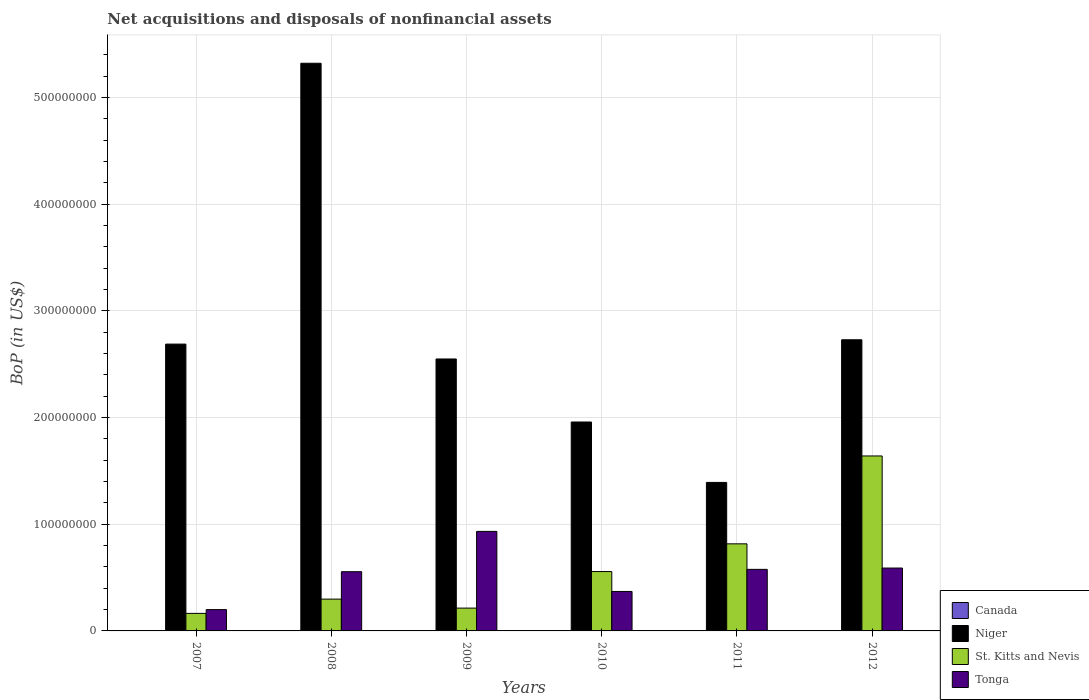Are the number of bars per tick equal to the number of legend labels?
Make the answer very short. No. How many bars are there on the 4th tick from the left?
Your answer should be very brief. 3. What is the Balance of Payments in Tonga in 2010?
Give a very brief answer. 3.70e+07. Across all years, what is the maximum Balance of Payments in Tonga?
Make the answer very short. 9.33e+07. Across all years, what is the minimum Balance of Payments in Niger?
Ensure brevity in your answer.  1.39e+08. What is the total Balance of Payments in Niger in the graph?
Your response must be concise. 1.66e+09. What is the difference between the Balance of Payments in St. Kitts and Nevis in 2007 and that in 2012?
Ensure brevity in your answer.  -1.48e+08. What is the difference between the Balance of Payments in Niger in 2009 and the Balance of Payments in St. Kitts and Nevis in 2012?
Offer a terse response. 9.09e+07. What is the average Balance of Payments in Tonga per year?
Give a very brief answer. 5.37e+07. In the year 2010, what is the difference between the Balance of Payments in St. Kitts and Nevis and Balance of Payments in Tonga?
Your answer should be very brief. 1.87e+07. What is the ratio of the Balance of Payments in Niger in 2009 to that in 2012?
Offer a very short reply. 0.93. Is the Balance of Payments in Niger in 2007 less than that in 2010?
Make the answer very short. No. Is the difference between the Balance of Payments in St. Kitts and Nevis in 2007 and 2009 greater than the difference between the Balance of Payments in Tonga in 2007 and 2009?
Offer a terse response. Yes. What is the difference between the highest and the second highest Balance of Payments in Tonga?
Your response must be concise. 3.43e+07. What is the difference between the highest and the lowest Balance of Payments in Niger?
Provide a short and direct response. 3.93e+08. Is it the case that in every year, the sum of the Balance of Payments in Tonga and Balance of Payments in Niger is greater than the Balance of Payments in St. Kitts and Nevis?
Your answer should be compact. Yes. Are all the bars in the graph horizontal?
Your answer should be compact. No. How many years are there in the graph?
Your response must be concise. 6. Are the values on the major ticks of Y-axis written in scientific E-notation?
Your response must be concise. No. Does the graph contain any zero values?
Your response must be concise. Yes. Where does the legend appear in the graph?
Ensure brevity in your answer.  Bottom right. What is the title of the graph?
Your response must be concise. Net acquisitions and disposals of nonfinancial assets. Does "Lithuania" appear as one of the legend labels in the graph?
Ensure brevity in your answer.  No. What is the label or title of the X-axis?
Your answer should be very brief. Years. What is the label or title of the Y-axis?
Your answer should be very brief. BoP (in US$). What is the BoP (in US$) in Canada in 2007?
Keep it short and to the point. 0. What is the BoP (in US$) of Niger in 2007?
Offer a terse response. 2.69e+08. What is the BoP (in US$) in St. Kitts and Nevis in 2007?
Your answer should be very brief. 1.64e+07. What is the BoP (in US$) of Tonga in 2007?
Give a very brief answer. 2.00e+07. What is the BoP (in US$) in Niger in 2008?
Your answer should be very brief. 5.32e+08. What is the BoP (in US$) of St. Kitts and Nevis in 2008?
Make the answer very short. 2.98e+07. What is the BoP (in US$) of Tonga in 2008?
Provide a succinct answer. 5.55e+07. What is the BoP (in US$) in Canada in 2009?
Provide a succinct answer. 0. What is the BoP (in US$) in Niger in 2009?
Keep it short and to the point. 2.55e+08. What is the BoP (in US$) of St. Kitts and Nevis in 2009?
Provide a succinct answer. 2.14e+07. What is the BoP (in US$) of Tonga in 2009?
Your answer should be very brief. 9.33e+07. What is the BoP (in US$) in Canada in 2010?
Make the answer very short. 0. What is the BoP (in US$) in Niger in 2010?
Offer a very short reply. 1.96e+08. What is the BoP (in US$) of St. Kitts and Nevis in 2010?
Give a very brief answer. 5.56e+07. What is the BoP (in US$) of Tonga in 2010?
Offer a very short reply. 3.70e+07. What is the BoP (in US$) of Canada in 2011?
Your answer should be compact. 0. What is the BoP (in US$) of Niger in 2011?
Provide a short and direct response. 1.39e+08. What is the BoP (in US$) of St. Kitts and Nevis in 2011?
Provide a short and direct response. 8.16e+07. What is the BoP (in US$) of Tonga in 2011?
Give a very brief answer. 5.77e+07. What is the BoP (in US$) in Canada in 2012?
Ensure brevity in your answer.  0. What is the BoP (in US$) of Niger in 2012?
Give a very brief answer. 2.73e+08. What is the BoP (in US$) of St. Kitts and Nevis in 2012?
Provide a succinct answer. 1.64e+08. What is the BoP (in US$) of Tonga in 2012?
Keep it short and to the point. 5.89e+07. Across all years, what is the maximum BoP (in US$) of Niger?
Provide a succinct answer. 5.32e+08. Across all years, what is the maximum BoP (in US$) in St. Kitts and Nevis?
Keep it short and to the point. 1.64e+08. Across all years, what is the maximum BoP (in US$) of Tonga?
Keep it short and to the point. 9.33e+07. Across all years, what is the minimum BoP (in US$) in Niger?
Ensure brevity in your answer.  1.39e+08. Across all years, what is the minimum BoP (in US$) of St. Kitts and Nevis?
Your response must be concise. 1.64e+07. Across all years, what is the minimum BoP (in US$) in Tonga?
Keep it short and to the point. 2.00e+07. What is the total BoP (in US$) of Niger in the graph?
Ensure brevity in your answer.  1.66e+09. What is the total BoP (in US$) in St. Kitts and Nevis in the graph?
Ensure brevity in your answer.  3.69e+08. What is the total BoP (in US$) in Tonga in the graph?
Offer a terse response. 3.22e+08. What is the difference between the BoP (in US$) of Niger in 2007 and that in 2008?
Make the answer very short. -2.63e+08. What is the difference between the BoP (in US$) of St. Kitts and Nevis in 2007 and that in 2008?
Ensure brevity in your answer.  -1.34e+07. What is the difference between the BoP (in US$) of Tonga in 2007 and that in 2008?
Your response must be concise. -3.55e+07. What is the difference between the BoP (in US$) in Niger in 2007 and that in 2009?
Keep it short and to the point. 1.39e+07. What is the difference between the BoP (in US$) of St. Kitts and Nevis in 2007 and that in 2009?
Offer a terse response. -4.94e+06. What is the difference between the BoP (in US$) in Tonga in 2007 and that in 2009?
Keep it short and to the point. -7.33e+07. What is the difference between the BoP (in US$) of Niger in 2007 and that in 2010?
Your answer should be compact. 7.30e+07. What is the difference between the BoP (in US$) in St. Kitts and Nevis in 2007 and that in 2010?
Provide a succinct answer. -3.92e+07. What is the difference between the BoP (in US$) of Tonga in 2007 and that in 2010?
Your answer should be compact. -1.70e+07. What is the difference between the BoP (in US$) of Niger in 2007 and that in 2011?
Your answer should be compact. 1.30e+08. What is the difference between the BoP (in US$) in St. Kitts and Nevis in 2007 and that in 2011?
Offer a very short reply. -6.52e+07. What is the difference between the BoP (in US$) in Tonga in 2007 and that in 2011?
Ensure brevity in your answer.  -3.77e+07. What is the difference between the BoP (in US$) of Niger in 2007 and that in 2012?
Keep it short and to the point. -4.05e+06. What is the difference between the BoP (in US$) in St. Kitts and Nevis in 2007 and that in 2012?
Keep it short and to the point. -1.48e+08. What is the difference between the BoP (in US$) of Tonga in 2007 and that in 2012?
Your answer should be compact. -3.90e+07. What is the difference between the BoP (in US$) in Niger in 2008 and that in 2009?
Keep it short and to the point. 2.77e+08. What is the difference between the BoP (in US$) of St. Kitts and Nevis in 2008 and that in 2009?
Offer a terse response. 8.42e+06. What is the difference between the BoP (in US$) in Tonga in 2008 and that in 2009?
Give a very brief answer. -3.78e+07. What is the difference between the BoP (in US$) of Niger in 2008 and that in 2010?
Your answer should be very brief. 3.36e+08. What is the difference between the BoP (in US$) of St. Kitts and Nevis in 2008 and that in 2010?
Your response must be concise. -2.58e+07. What is the difference between the BoP (in US$) in Tonga in 2008 and that in 2010?
Your answer should be compact. 1.85e+07. What is the difference between the BoP (in US$) in Niger in 2008 and that in 2011?
Your answer should be very brief. 3.93e+08. What is the difference between the BoP (in US$) of St. Kitts and Nevis in 2008 and that in 2011?
Provide a succinct answer. -5.18e+07. What is the difference between the BoP (in US$) of Tonga in 2008 and that in 2011?
Give a very brief answer. -2.19e+06. What is the difference between the BoP (in US$) in Niger in 2008 and that in 2012?
Your answer should be compact. 2.59e+08. What is the difference between the BoP (in US$) of St. Kitts and Nevis in 2008 and that in 2012?
Make the answer very short. -1.34e+08. What is the difference between the BoP (in US$) in Tonga in 2008 and that in 2012?
Give a very brief answer. -3.43e+06. What is the difference between the BoP (in US$) of Niger in 2009 and that in 2010?
Provide a succinct answer. 5.91e+07. What is the difference between the BoP (in US$) in St. Kitts and Nevis in 2009 and that in 2010?
Your response must be concise. -3.43e+07. What is the difference between the BoP (in US$) of Tonga in 2009 and that in 2010?
Give a very brief answer. 5.63e+07. What is the difference between the BoP (in US$) of Niger in 2009 and that in 2011?
Make the answer very short. 1.16e+08. What is the difference between the BoP (in US$) in St. Kitts and Nevis in 2009 and that in 2011?
Your response must be concise. -6.02e+07. What is the difference between the BoP (in US$) of Tonga in 2009 and that in 2011?
Offer a very short reply. 3.56e+07. What is the difference between the BoP (in US$) of Niger in 2009 and that in 2012?
Provide a short and direct response. -1.80e+07. What is the difference between the BoP (in US$) in St. Kitts and Nevis in 2009 and that in 2012?
Offer a very short reply. -1.43e+08. What is the difference between the BoP (in US$) of Tonga in 2009 and that in 2012?
Provide a succinct answer. 3.43e+07. What is the difference between the BoP (in US$) of Niger in 2010 and that in 2011?
Your response must be concise. 5.66e+07. What is the difference between the BoP (in US$) of St. Kitts and Nevis in 2010 and that in 2011?
Provide a succinct answer. -2.60e+07. What is the difference between the BoP (in US$) in Tonga in 2010 and that in 2011?
Your response must be concise. -2.07e+07. What is the difference between the BoP (in US$) in Niger in 2010 and that in 2012?
Provide a short and direct response. -7.71e+07. What is the difference between the BoP (in US$) in St. Kitts and Nevis in 2010 and that in 2012?
Make the answer very short. -1.08e+08. What is the difference between the BoP (in US$) of Tonga in 2010 and that in 2012?
Keep it short and to the point. -2.20e+07. What is the difference between the BoP (in US$) of Niger in 2011 and that in 2012?
Offer a very short reply. -1.34e+08. What is the difference between the BoP (in US$) of St. Kitts and Nevis in 2011 and that in 2012?
Your answer should be very brief. -8.24e+07. What is the difference between the BoP (in US$) in Tonga in 2011 and that in 2012?
Make the answer very short. -1.24e+06. What is the difference between the BoP (in US$) in Niger in 2007 and the BoP (in US$) in St. Kitts and Nevis in 2008?
Make the answer very short. 2.39e+08. What is the difference between the BoP (in US$) in Niger in 2007 and the BoP (in US$) in Tonga in 2008?
Ensure brevity in your answer.  2.13e+08. What is the difference between the BoP (in US$) of St. Kitts and Nevis in 2007 and the BoP (in US$) of Tonga in 2008?
Your answer should be compact. -3.91e+07. What is the difference between the BoP (in US$) of Niger in 2007 and the BoP (in US$) of St. Kitts and Nevis in 2009?
Your response must be concise. 2.47e+08. What is the difference between the BoP (in US$) in Niger in 2007 and the BoP (in US$) in Tonga in 2009?
Ensure brevity in your answer.  1.76e+08. What is the difference between the BoP (in US$) of St. Kitts and Nevis in 2007 and the BoP (in US$) of Tonga in 2009?
Your answer should be compact. -7.68e+07. What is the difference between the BoP (in US$) in Niger in 2007 and the BoP (in US$) in St. Kitts and Nevis in 2010?
Provide a succinct answer. 2.13e+08. What is the difference between the BoP (in US$) in Niger in 2007 and the BoP (in US$) in Tonga in 2010?
Offer a terse response. 2.32e+08. What is the difference between the BoP (in US$) of St. Kitts and Nevis in 2007 and the BoP (in US$) of Tonga in 2010?
Keep it short and to the point. -2.05e+07. What is the difference between the BoP (in US$) in Niger in 2007 and the BoP (in US$) in St. Kitts and Nevis in 2011?
Keep it short and to the point. 1.87e+08. What is the difference between the BoP (in US$) of Niger in 2007 and the BoP (in US$) of Tonga in 2011?
Keep it short and to the point. 2.11e+08. What is the difference between the BoP (in US$) in St. Kitts and Nevis in 2007 and the BoP (in US$) in Tonga in 2011?
Your answer should be very brief. -4.13e+07. What is the difference between the BoP (in US$) in Niger in 2007 and the BoP (in US$) in St. Kitts and Nevis in 2012?
Offer a terse response. 1.05e+08. What is the difference between the BoP (in US$) in Niger in 2007 and the BoP (in US$) in Tonga in 2012?
Provide a succinct answer. 2.10e+08. What is the difference between the BoP (in US$) of St. Kitts and Nevis in 2007 and the BoP (in US$) of Tonga in 2012?
Provide a succinct answer. -4.25e+07. What is the difference between the BoP (in US$) in Niger in 2008 and the BoP (in US$) in St. Kitts and Nevis in 2009?
Provide a succinct answer. 5.11e+08. What is the difference between the BoP (in US$) in Niger in 2008 and the BoP (in US$) in Tonga in 2009?
Provide a succinct answer. 4.39e+08. What is the difference between the BoP (in US$) in St. Kitts and Nevis in 2008 and the BoP (in US$) in Tonga in 2009?
Make the answer very short. -6.35e+07. What is the difference between the BoP (in US$) in Niger in 2008 and the BoP (in US$) in St. Kitts and Nevis in 2010?
Provide a short and direct response. 4.76e+08. What is the difference between the BoP (in US$) in Niger in 2008 and the BoP (in US$) in Tonga in 2010?
Ensure brevity in your answer.  4.95e+08. What is the difference between the BoP (in US$) of St. Kitts and Nevis in 2008 and the BoP (in US$) of Tonga in 2010?
Provide a succinct answer. -7.18e+06. What is the difference between the BoP (in US$) in Niger in 2008 and the BoP (in US$) in St. Kitts and Nevis in 2011?
Ensure brevity in your answer.  4.50e+08. What is the difference between the BoP (in US$) of Niger in 2008 and the BoP (in US$) of Tonga in 2011?
Your response must be concise. 4.74e+08. What is the difference between the BoP (in US$) in St. Kitts and Nevis in 2008 and the BoP (in US$) in Tonga in 2011?
Provide a succinct answer. -2.79e+07. What is the difference between the BoP (in US$) of Niger in 2008 and the BoP (in US$) of St. Kitts and Nevis in 2012?
Give a very brief answer. 3.68e+08. What is the difference between the BoP (in US$) in Niger in 2008 and the BoP (in US$) in Tonga in 2012?
Your answer should be very brief. 4.73e+08. What is the difference between the BoP (in US$) of St. Kitts and Nevis in 2008 and the BoP (in US$) of Tonga in 2012?
Offer a terse response. -2.91e+07. What is the difference between the BoP (in US$) of Niger in 2009 and the BoP (in US$) of St. Kitts and Nevis in 2010?
Keep it short and to the point. 1.99e+08. What is the difference between the BoP (in US$) in Niger in 2009 and the BoP (in US$) in Tonga in 2010?
Keep it short and to the point. 2.18e+08. What is the difference between the BoP (in US$) of St. Kitts and Nevis in 2009 and the BoP (in US$) of Tonga in 2010?
Ensure brevity in your answer.  -1.56e+07. What is the difference between the BoP (in US$) in Niger in 2009 and the BoP (in US$) in St. Kitts and Nevis in 2011?
Your response must be concise. 1.73e+08. What is the difference between the BoP (in US$) in Niger in 2009 and the BoP (in US$) in Tonga in 2011?
Your answer should be compact. 1.97e+08. What is the difference between the BoP (in US$) in St. Kitts and Nevis in 2009 and the BoP (in US$) in Tonga in 2011?
Give a very brief answer. -3.63e+07. What is the difference between the BoP (in US$) of Niger in 2009 and the BoP (in US$) of St. Kitts and Nevis in 2012?
Your response must be concise. 9.09e+07. What is the difference between the BoP (in US$) in Niger in 2009 and the BoP (in US$) in Tonga in 2012?
Ensure brevity in your answer.  1.96e+08. What is the difference between the BoP (in US$) in St. Kitts and Nevis in 2009 and the BoP (in US$) in Tonga in 2012?
Offer a terse response. -3.76e+07. What is the difference between the BoP (in US$) in Niger in 2010 and the BoP (in US$) in St. Kitts and Nevis in 2011?
Provide a succinct answer. 1.14e+08. What is the difference between the BoP (in US$) in Niger in 2010 and the BoP (in US$) in Tonga in 2011?
Your response must be concise. 1.38e+08. What is the difference between the BoP (in US$) of St. Kitts and Nevis in 2010 and the BoP (in US$) of Tonga in 2011?
Your answer should be compact. -2.05e+06. What is the difference between the BoP (in US$) in Niger in 2010 and the BoP (in US$) in St. Kitts and Nevis in 2012?
Keep it short and to the point. 3.18e+07. What is the difference between the BoP (in US$) in Niger in 2010 and the BoP (in US$) in Tonga in 2012?
Your response must be concise. 1.37e+08. What is the difference between the BoP (in US$) in St. Kitts and Nevis in 2010 and the BoP (in US$) in Tonga in 2012?
Give a very brief answer. -3.30e+06. What is the difference between the BoP (in US$) of Niger in 2011 and the BoP (in US$) of St. Kitts and Nevis in 2012?
Keep it short and to the point. -2.48e+07. What is the difference between the BoP (in US$) of Niger in 2011 and the BoP (in US$) of Tonga in 2012?
Keep it short and to the point. 8.03e+07. What is the difference between the BoP (in US$) in St. Kitts and Nevis in 2011 and the BoP (in US$) in Tonga in 2012?
Provide a short and direct response. 2.27e+07. What is the average BoP (in US$) of Canada per year?
Ensure brevity in your answer.  0. What is the average BoP (in US$) in Niger per year?
Your answer should be very brief. 2.77e+08. What is the average BoP (in US$) of St. Kitts and Nevis per year?
Provide a succinct answer. 6.15e+07. What is the average BoP (in US$) of Tonga per year?
Ensure brevity in your answer.  5.37e+07. In the year 2007, what is the difference between the BoP (in US$) of Niger and BoP (in US$) of St. Kitts and Nevis?
Ensure brevity in your answer.  2.52e+08. In the year 2007, what is the difference between the BoP (in US$) of Niger and BoP (in US$) of Tonga?
Your answer should be compact. 2.49e+08. In the year 2007, what is the difference between the BoP (in US$) in St. Kitts and Nevis and BoP (in US$) in Tonga?
Provide a short and direct response. -3.53e+06. In the year 2008, what is the difference between the BoP (in US$) in Niger and BoP (in US$) in St. Kitts and Nevis?
Make the answer very short. 5.02e+08. In the year 2008, what is the difference between the BoP (in US$) of Niger and BoP (in US$) of Tonga?
Offer a very short reply. 4.77e+08. In the year 2008, what is the difference between the BoP (in US$) of St. Kitts and Nevis and BoP (in US$) of Tonga?
Your answer should be very brief. -2.57e+07. In the year 2009, what is the difference between the BoP (in US$) in Niger and BoP (in US$) in St. Kitts and Nevis?
Provide a short and direct response. 2.34e+08. In the year 2009, what is the difference between the BoP (in US$) of Niger and BoP (in US$) of Tonga?
Make the answer very short. 1.62e+08. In the year 2009, what is the difference between the BoP (in US$) in St. Kitts and Nevis and BoP (in US$) in Tonga?
Make the answer very short. -7.19e+07. In the year 2010, what is the difference between the BoP (in US$) in Niger and BoP (in US$) in St. Kitts and Nevis?
Provide a short and direct response. 1.40e+08. In the year 2010, what is the difference between the BoP (in US$) of Niger and BoP (in US$) of Tonga?
Ensure brevity in your answer.  1.59e+08. In the year 2010, what is the difference between the BoP (in US$) of St. Kitts and Nevis and BoP (in US$) of Tonga?
Keep it short and to the point. 1.87e+07. In the year 2011, what is the difference between the BoP (in US$) of Niger and BoP (in US$) of St. Kitts and Nevis?
Keep it short and to the point. 5.76e+07. In the year 2011, what is the difference between the BoP (in US$) of Niger and BoP (in US$) of Tonga?
Your response must be concise. 8.15e+07. In the year 2011, what is the difference between the BoP (in US$) in St. Kitts and Nevis and BoP (in US$) in Tonga?
Provide a short and direct response. 2.39e+07. In the year 2012, what is the difference between the BoP (in US$) of Niger and BoP (in US$) of St. Kitts and Nevis?
Provide a short and direct response. 1.09e+08. In the year 2012, what is the difference between the BoP (in US$) in Niger and BoP (in US$) in Tonga?
Ensure brevity in your answer.  2.14e+08. In the year 2012, what is the difference between the BoP (in US$) in St. Kitts and Nevis and BoP (in US$) in Tonga?
Give a very brief answer. 1.05e+08. What is the ratio of the BoP (in US$) of Niger in 2007 to that in 2008?
Your response must be concise. 0.51. What is the ratio of the BoP (in US$) of St. Kitts and Nevis in 2007 to that in 2008?
Ensure brevity in your answer.  0.55. What is the ratio of the BoP (in US$) in Tonga in 2007 to that in 2008?
Your response must be concise. 0.36. What is the ratio of the BoP (in US$) of Niger in 2007 to that in 2009?
Make the answer very short. 1.05. What is the ratio of the BoP (in US$) of St. Kitts and Nevis in 2007 to that in 2009?
Your response must be concise. 0.77. What is the ratio of the BoP (in US$) in Tonga in 2007 to that in 2009?
Your response must be concise. 0.21. What is the ratio of the BoP (in US$) in Niger in 2007 to that in 2010?
Offer a terse response. 1.37. What is the ratio of the BoP (in US$) of St. Kitts and Nevis in 2007 to that in 2010?
Your answer should be very brief. 0.3. What is the ratio of the BoP (in US$) of Tonga in 2007 to that in 2010?
Give a very brief answer. 0.54. What is the ratio of the BoP (in US$) of Niger in 2007 to that in 2011?
Give a very brief answer. 1.93. What is the ratio of the BoP (in US$) in St. Kitts and Nevis in 2007 to that in 2011?
Ensure brevity in your answer.  0.2. What is the ratio of the BoP (in US$) in Tonga in 2007 to that in 2011?
Your answer should be compact. 0.35. What is the ratio of the BoP (in US$) of Niger in 2007 to that in 2012?
Your answer should be compact. 0.99. What is the ratio of the BoP (in US$) in St. Kitts and Nevis in 2007 to that in 2012?
Offer a terse response. 0.1. What is the ratio of the BoP (in US$) in Tonga in 2007 to that in 2012?
Make the answer very short. 0.34. What is the ratio of the BoP (in US$) in Niger in 2008 to that in 2009?
Offer a terse response. 2.09. What is the ratio of the BoP (in US$) of St. Kitts and Nevis in 2008 to that in 2009?
Your answer should be very brief. 1.39. What is the ratio of the BoP (in US$) of Tonga in 2008 to that in 2009?
Your answer should be compact. 0.6. What is the ratio of the BoP (in US$) of Niger in 2008 to that in 2010?
Your answer should be compact. 2.72. What is the ratio of the BoP (in US$) of St. Kitts and Nevis in 2008 to that in 2010?
Offer a very short reply. 0.54. What is the ratio of the BoP (in US$) in Tonga in 2008 to that in 2010?
Provide a short and direct response. 1.5. What is the ratio of the BoP (in US$) of Niger in 2008 to that in 2011?
Your answer should be compact. 3.82. What is the ratio of the BoP (in US$) of St. Kitts and Nevis in 2008 to that in 2011?
Provide a short and direct response. 0.37. What is the ratio of the BoP (in US$) of Tonga in 2008 to that in 2011?
Offer a terse response. 0.96. What is the ratio of the BoP (in US$) in Niger in 2008 to that in 2012?
Your answer should be very brief. 1.95. What is the ratio of the BoP (in US$) in St. Kitts and Nevis in 2008 to that in 2012?
Your answer should be very brief. 0.18. What is the ratio of the BoP (in US$) of Tonga in 2008 to that in 2012?
Your answer should be very brief. 0.94. What is the ratio of the BoP (in US$) of Niger in 2009 to that in 2010?
Provide a succinct answer. 1.3. What is the ratio of the BoP (in US$) in St. Kitts and Nevis in 2009 to that in 2010?
Offer a terse response. 0.38. What is the ratio of the BoP (in US$) in Tonga in 2009 to that in 2010?
Offer a very short reply. 2.52. What is the ratio of the BoP (in US$) of Niger in 2009 to that in 2011?
Your answer should be compact. 1.83. What is the ratio of the BoP (in US$) in St. Kitts and Nevis in 2009 to that in 2011?
Offer a very short reply. 0.26. What is the ratio of the BoP (in US$) in Tonga in 2009 to that in 2011?
Your response must be concise. 1.62. What is the ratio of the BoP (in US$) in Niger in 2009 to that in 2012?
Your answer should be very brief. 0.93. What is the ratio of the BoP (in US$) of St. Kitts and Nevis in 2009 to that in 2012?
Give a very brief answer. 0.13. What is the ratio of the BoP (in US$) in Tonga in 2009 to that in 2012?
Ensure brevity in your answer.  1.58. What is the ratio of the BoP (in US$) of Niger in 2010 to that in 2011?
Your response must be concise. 1.41. What is the ratio of the BoP (in US$) of St. Kitts and Nevis in 2010 to that in 2011?
Your response must be concise. 0.68. What is the ratio of the BoP (in US$) in Tonga in 2010 to that in 2011?
Provide a succinct answer. 0.64. What is the ratio of the BoP (in US$) of Niger in 2010 to that in 2012?
Keep it short and to the point. 0.72. What is the ratio of the BoP (in US$) of St. Kitts and Nevis in 2010 to that in 2012?
Give a very brief answer. 0.34. What is the ratio of the BoP (in US$) of Tonga in 2010 to that in 2012?
Make the answer very short. 0.63. What is the ratio of the BoP (in US$) of Niger in 2011 to that in 2012?
Make the answer very short. 0.51. What is the ratio of the BoP (in US$) of St. Kitts and Nevis in 2011 to that in 2012?
Ensure brevity in your answer.  0.5. What is the ratio of the BoP (in US$) of Tonga in 2011 to that in 2012?
Your response must be concise. 0.98. What is the difference between the highest and the second highest BoP (in US$) in Niger?
Provide a succinct answer. 2.59e+08. What is the difference between the highest and the second highest BoP (in US$) in St. Kitts and Nevis?
Your answer should be very brief. 8.24e+07. What is the difference between the highest and the second highest BoP (in US$) in Tonga?
Your response must be concise. 3.43e+07. What is the difference between the highest and the lowest BoP (in US$) in Niger?
Offer a terse response. 3.93e+08. What is the difference between the highest and the lowest BoP (in US$) of St. Kitts and Nevis?
Your response must be concise. 1.48e+08. What is the difference between the highest and the lowest BoP (in US$) of Tonga?
Provide a short and direct response. 7.33e+07. 